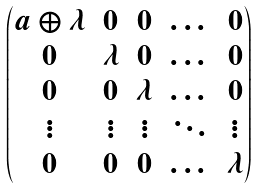Convert formula to latex. <formula><loc_0><loc_0><loc_500><loc_500>\begin{pmatrix} a \oplus \lambda & 0 & 0 & \dots & 0 \\ 0 & \lambda & 0 & \dots & 0 \\ 0 & 0 & \lambda & \dots & 0 \\ \vdots & \vdots & \vdots & \ddots & \vdots \\ 0 & 0 & 0 & \dots & \lambda \end{pmatrix}</formula> 